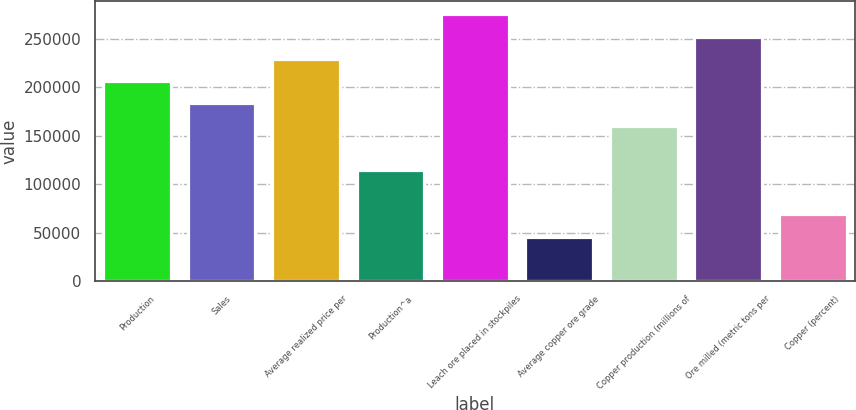<chart> <loc_0><loc_0><loc_500><loc_500><bar_chart><fcel>Production<fcel>Sales<fcel>Average realized price per<fcel>Production^a<fcel>Leach ore placed in stockpiles<fcel>Average copper ore grade<fcel>Copper production (millions of<fcel>Ore milled (metric tons per<fcel>Copper (percent)<nl><fcel>206370<fcel>183440<fcel>229300<fcel>114650<fcel>275160<fcel>45860<fcel>160510<fcel>252230<fcel>68790<nl></chart> 